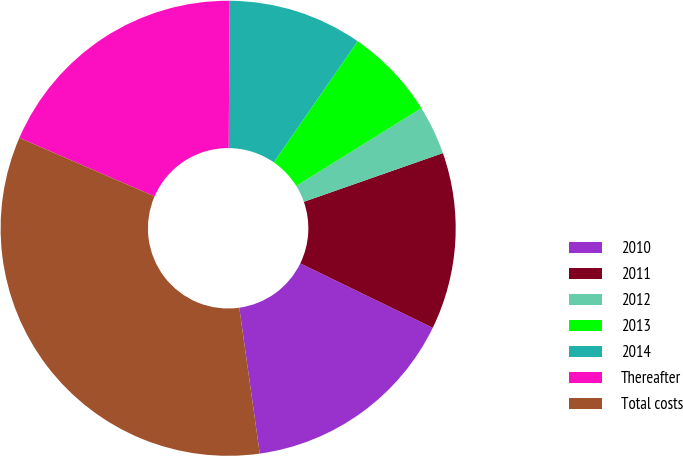Convert chart. <chart><loc_0><loc_0><loc_500><loc_500><pie_chart><fcel>2010<fcel>2011<fcel>2012<fcel>2013<fcel>2014<fcel>Thereafter<fcel>Total costs<nl><fcel>15.58%<fcel>12.56%<fcel>3.49%<fcel>6.51%<fcel>9.53%<fcel>18.6%<fcel>33.72%<nl></chart> 